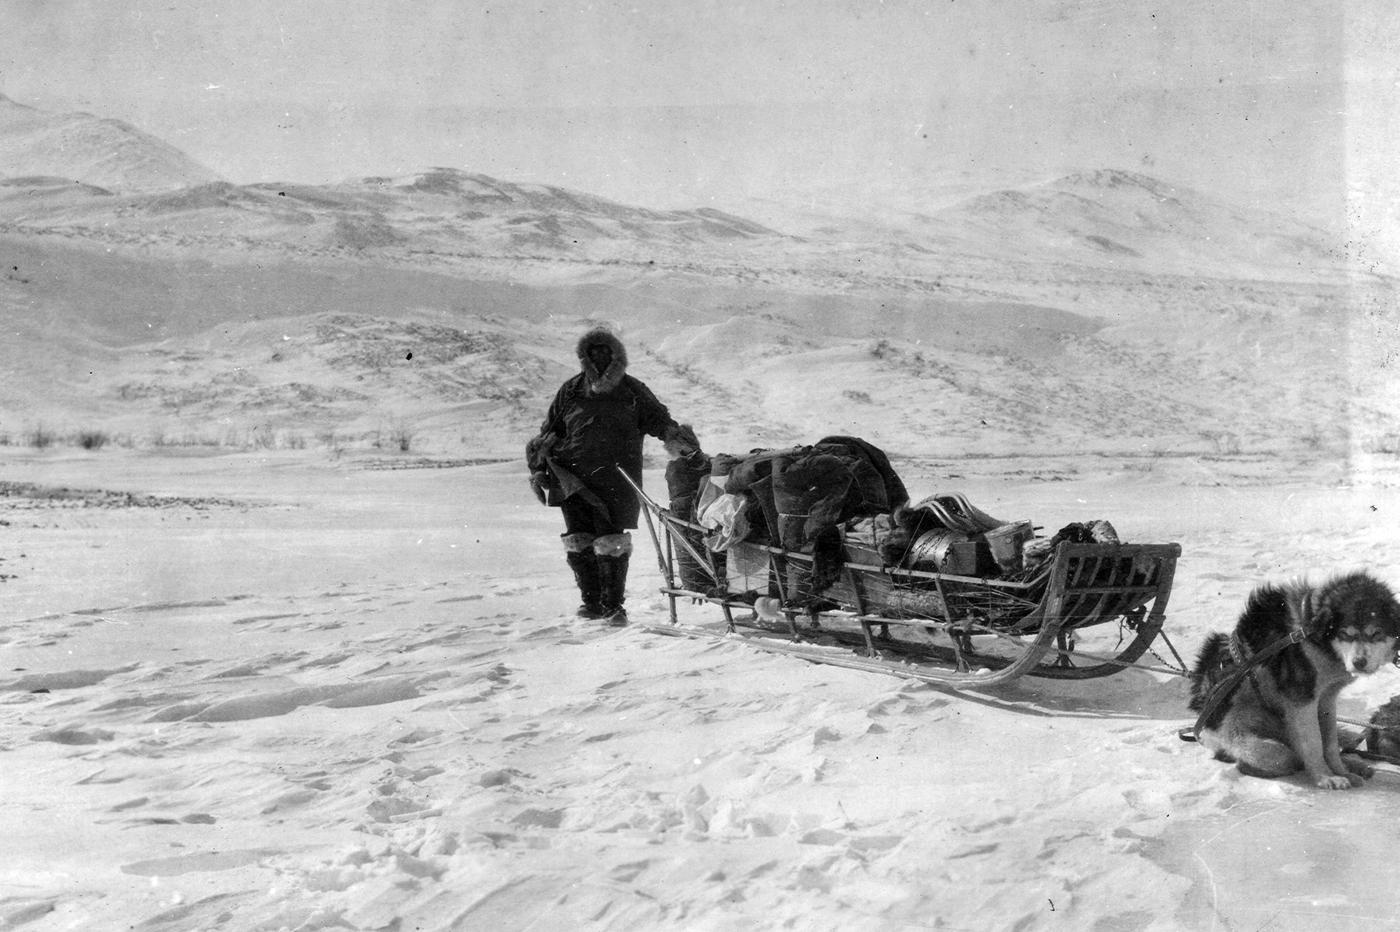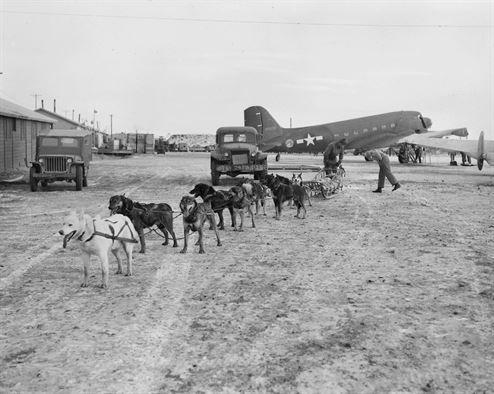The first image is the image on the left, the second image is the image on the right. Evaluate the accuracy of this statement regarding the images: "None of the lead dogs appear to be mostly white fur.". Is it true? Answer yes or no. No. The first image is the image on the left, the second image is the image on the right. Given the left and right images, does the statement "The left image shows a fur-hooded sled driver standing behind an old-fashioned long wooden sled, and the right image shows a dog sled near buildings." hold true? Answer yes or no. Yes. 